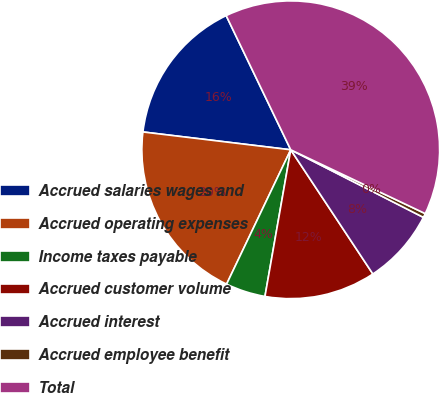<chart> <loc_0><loc_0><loc_500><loc_500><pie_chart><fcel>Accrued salaries wages and<fcel>Accrued operating expenses<fcel>Income taxes payable<fcel>Accrued customer volume<fcel>Accrued interest<fcel>Accrued employee benefit<fcel>Total<nl><fcel>15.95%<fcel>19.82%<fcel>4.32%<fcel>12.07%<fcel>8.2%<fcel>0.45%<fcel>39.19%<nl></chart> 